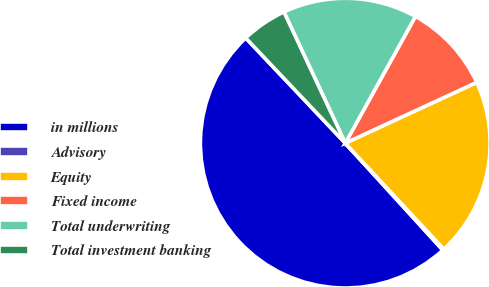<chart> <loc_0><loc_0><loc_500><loc_500><pie_chart><fcel>in millions<fcel>Advisory<fcel>Equity<fcel>Fixed income<fcel>Total underwriting<fcel>Total investment banking<nl><fcel>49.7%<fcel>0.15%<fcel>19.97%<fcel>10.06%<fcel>15.01%<fcel>5.1%<nl></chart> 